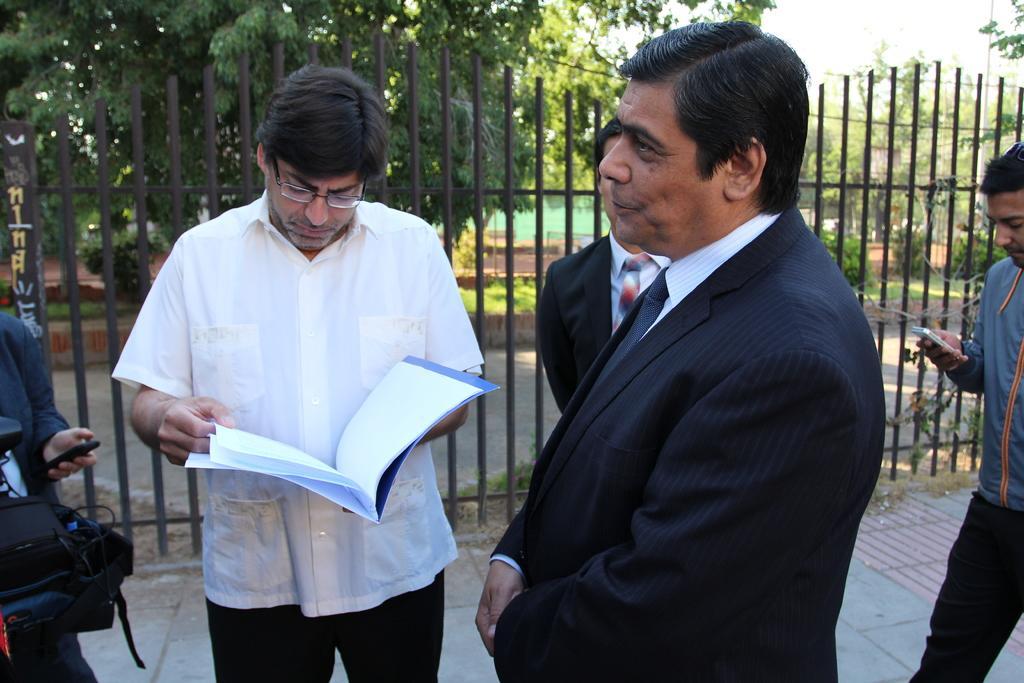Please provide a concise description of this image. In this Image I see 5 persons who are on the path and this man is holding a file in his hand and I see that these 2 are wearing suits, I can also see a bag over here. In the background I see the fence and the trees. 